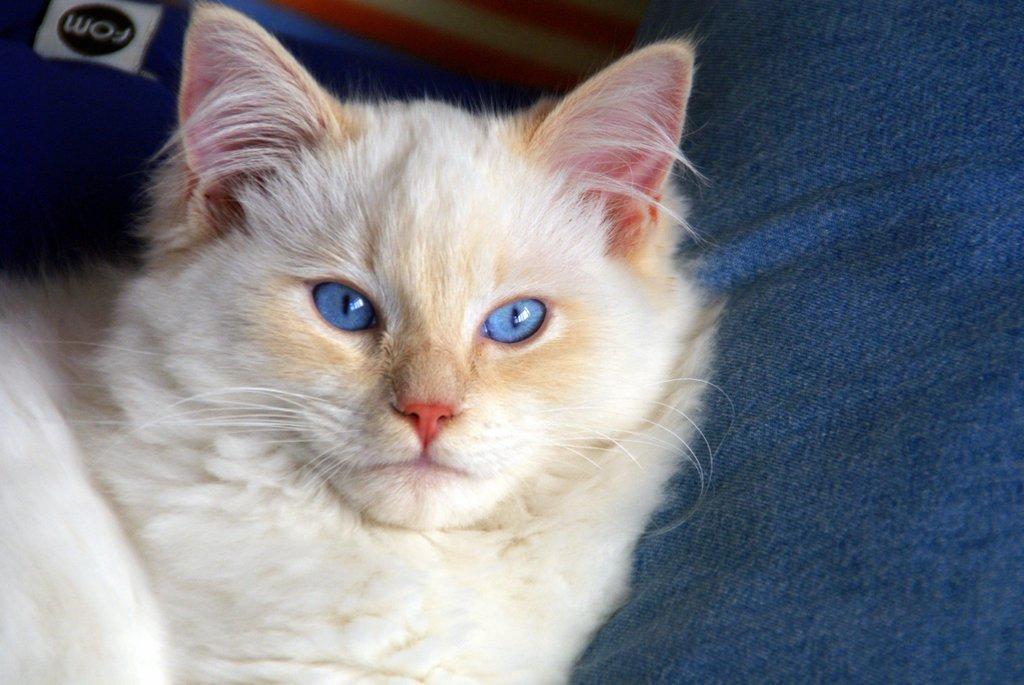How would you summarize this image in a sentence or two? In this image I see a cat which is of white and cream in color and I see the blue color cloth and I see alphabets over here. 